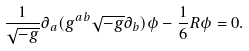Convert formula to latex. <formula><loc_0><loc_0><loc_500><loc_500>\frac { 1 } { \sqrt { - g } } \partial _ { a } ( g ^ { a b } \sqrt { - g } \partial _ { b } ) \phi - \frac { 1 } { 6 } R \phi = 0 .</formula> 